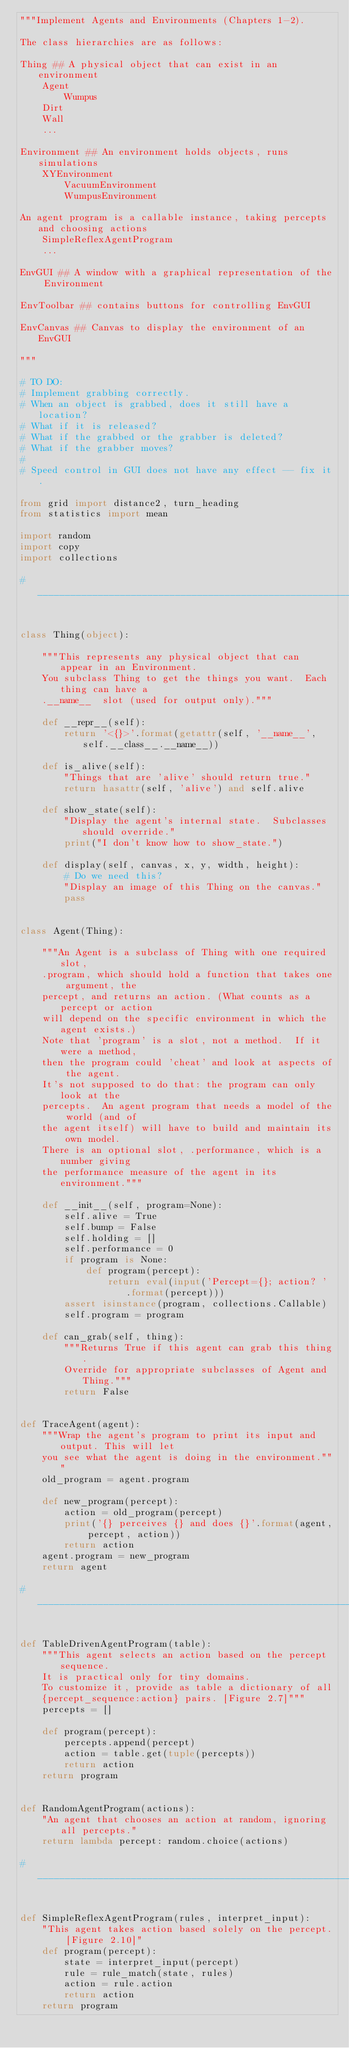Convert code to text. <code><loc_0><loc_0><loc_500><loc_500><_Python_>"""Implement Agents and Environments (Chapters 1-2).

The class hierarchies are as follows:

Thing ## A physical object that can exist in an environment
    Agent
        Wumpus
    Dirt
    Wall
    ...

Environment ## An environment holds objects, runs simulations
    XYEnvironment
        VacuumEnvironment
        WumpusEnvironment

An agent program is a callable instance, taking percepts and choosing actions
    SimpleReflexAgentProgram
    ...

EnvGUI ## A window with a graphical representation of the Environment

EnvToolbar ## contains buttons for controlling EnvGUI

EnvCanvas ## Canvas to display the environment of an EnvGUI

"""

# TO DO:
# Implement grabbing correctly.
# When an object is grabbed, does it still have a location?
# What if it is released?
# What if the grabbed or the grabber is deleted?
# What if the grabber moves?
#
# Speed control in GUI does not have any effect -- fix it.

from grid import distance2, turn_heading
from statistics import mean

import random
import copy
import collections

# ______________________________________________________________________________


class Thing(object):

    """This represents any physical object that can appear in an Environment.
    You subclass Thing to get the things you want.  Each thing can have a
    .__name__  slot (used for output only)."""

    def __repr__(self):
        return '<{}>'.format(getattr(self, '__name__', self.__class__.__name__))

    def is_alive(self):
        "Things that are 'alive' should return true."
        return hasattr(self, 'alive') and self.alive

    def show_state(self):
        "Display the agent's internal state.  Subclasses should override."
        print("I don't know how to show_state.")

    def display(self, canvas, x, y, width, height):
        # Do we need this?
        "Display an image of this Thing on the canvas."
        pass


class Agent(Thing):

    """An Agent is a subclass of Thing with one required slot,
    .program, which should hold a function that takes one argument, the
    percept, and returns an action. (What counts as a percept or action
    will depend on the specific environment in which the agent exists.)
    Note that 'program' is a slot, not a method.  If it were a method,
    then the program could 'cheat' and look at aspects of the agent.
    It's not supposed to do that: the program can only look at the
    percepts.  An agent program that needs a model of the world (and of
    the agent itself) will have to build and maintain its own model.
    There is an optional slot, .performance, which is a number giving
    the performance measure of the agent in its environment."""

    def __init__(self, program=None):
        self.alive = True
        self.bump = False
        self.holding = []
        self.performance = 0
        if program is None:
            def program(percept):
                return eval(input('Percept={}; action? ' .format(percept)))
        assert isinstance(program, collections.Callable)
        self.program = program

    def can_grab(self, thing):
        """Returns True if this agent can grab this thing.
        Override for appropriate subclasses of Agent and Thing."""
        return False


def TraceAgent(agent):
    """Wrap the agent's program to print its input and output. This will let
    you see what the agent is doing in the environment."""
    old_program = agent.program

    def new_program(percept):
        action = old_program(percept)
        print('{} perceives {} and does {}'.format(agent, percept, action))
        return action
    agent.program = new_program
    return agent

# ______________________________________________________________________________


def TableDrivenAgentProgram(table):
    """This agent selects an action based on the percept sequence.
    It is practical only for tiny domains.
    To customize it, provide as table a dictionary of all
    {percept_sequence:action} pairs. [Figure 2.7]"""
    percepts = []

    def program(percept):
        percepts.append(percept)
        action = table.get(tuple(percepts))
        return action
    return program


def RandomAgentProgram(actions):
    "An agent that chooses an action at random, ignoring all percepts."
    return lambda percept: random.choice(actions)

# ______________________________________________________________________________


def SimpleReflexAgentProgram(rules, interpret_input):
    "This agent takes action based solely on the percept. [Figure 2.10]"
    def program(percept):
        state = interpret_input(percept)
        rule = rule_match(state, rules)
        action = rule.action
        return action
    return program

</code> 